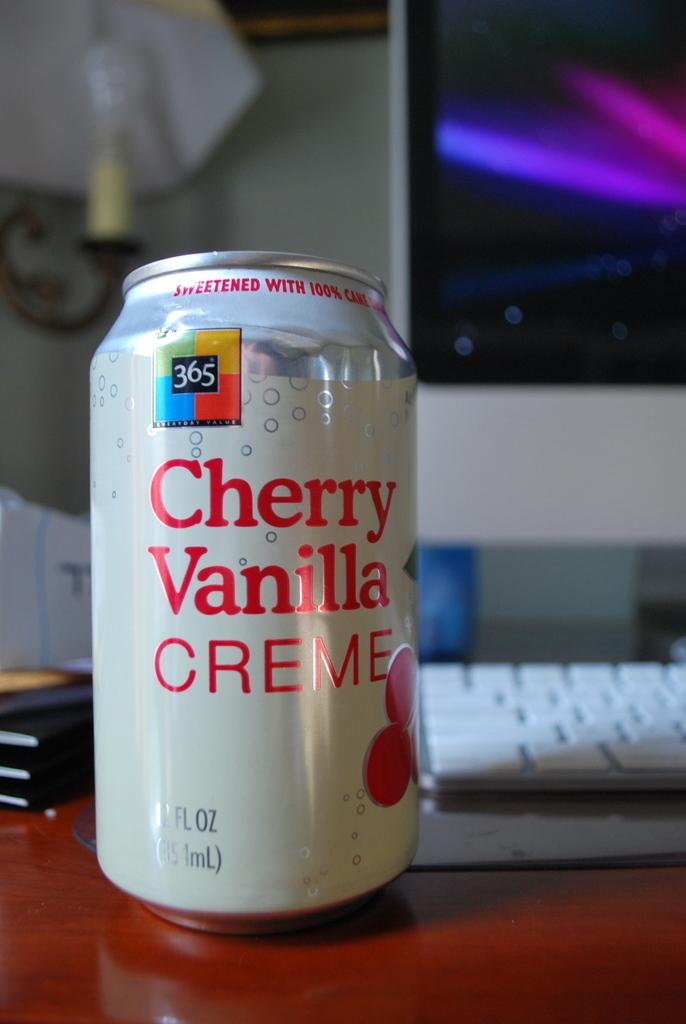<image>
Present a compact description of the photo's key features. a can of cherry vanilla creme soda is on the desk 